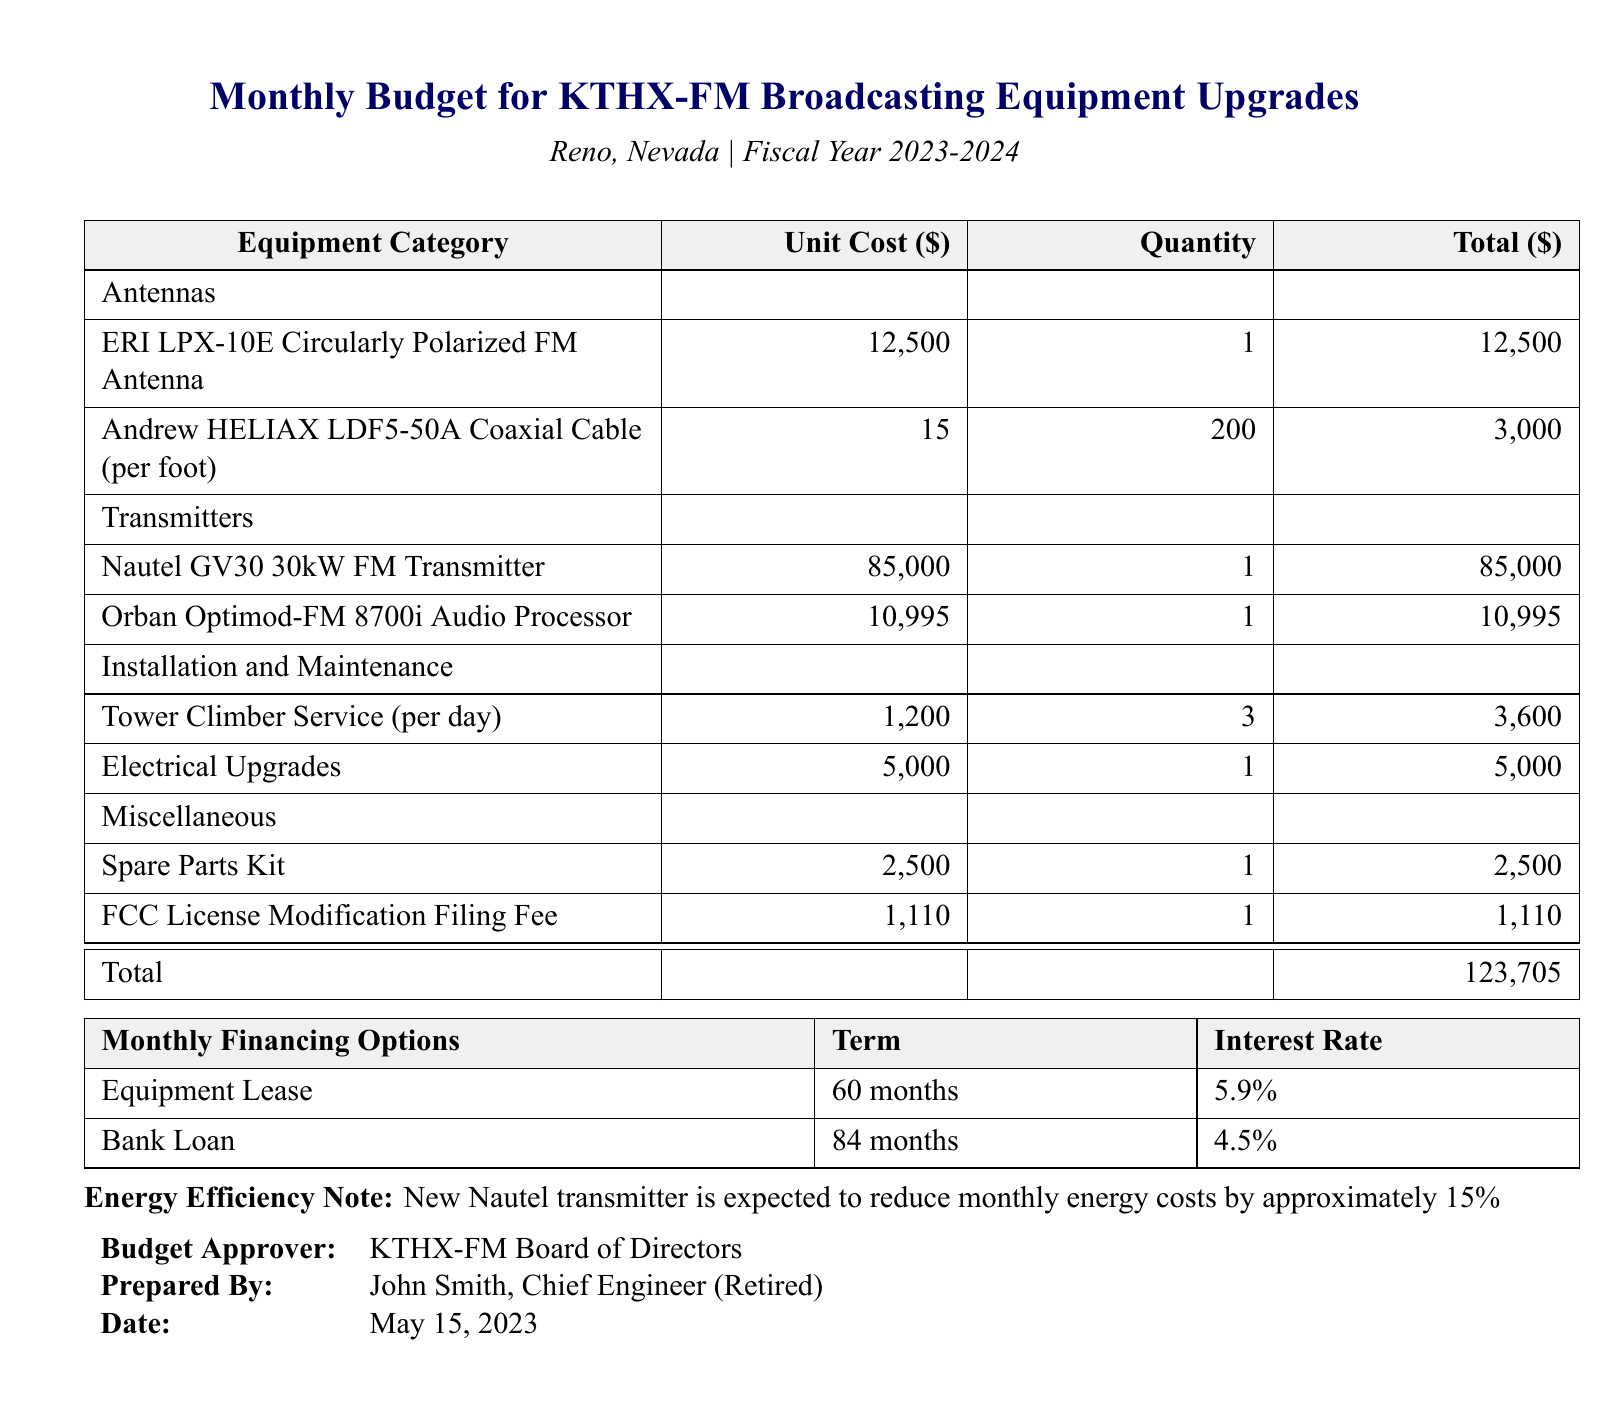what is the total cost for the new antennas? The total cost for the antennas is calculated from the unit cost of the ERI antenna and the coaxial cable, which is $12,500 + $3,000 = $15,500.
Answer: $15,500 how many Nautel GV30 transmitters are included in the budget? The budget lists 1 unit of the Nautel GV30 30kW FM Transmitter.
Answer: 1 what is the installation cost for the tower climber service? The cost is based on the daily rate multiplied by the number of days, which is $1,200 x 3 days = $3,600.
Answer: $3,600 who prepared the budget? The budget was prepared by John Smith, Chief Engineer (Retired).
Answer: John Smith what is the total budget amount? The total budget amount is stated at the bottom of the first table as $123,705.
Answer: $123,705 what is the interest rate for the equipment lease? The interest rate for the equipment lease is mentioned as 5.9%.
Answer: 5.9% how much does filing the FCC license modification cost? The FCC License Modification Filing Fee is listed as $1,110.
Answer: $1,110 how many months is the bank loan term? The term of the bank loan stated in the document is 84 months.
Answer: 84 months what is the expected reduction in monthly energy costs from the new transmitter? The document states that the new transmitter is expected to reduce monthly energy costs by approximately 15%.
Answer: 15% 